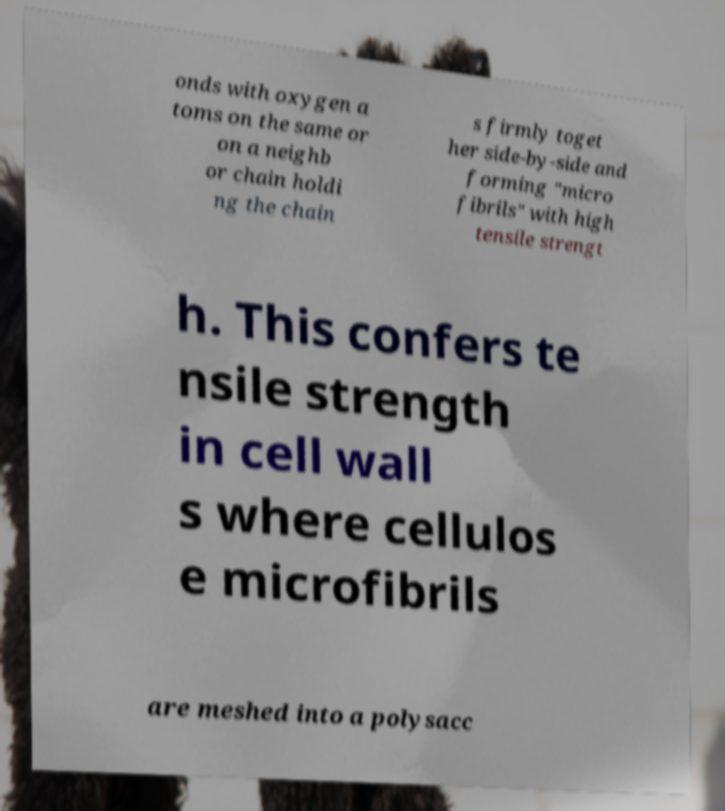Can you read and provide the text displayed in the image?This photo seems to have some interesting text. Can you extract and type it out for me? onds with oxygen a toms on the same or on a neighb or chain holdi ng the chain s firmly toget her side-by-side and forming "micro fibrils" with high tensile strengt h. This confers te nsile strength in cell wall s where cellulos e microfibrils are meshed into a polysacc 